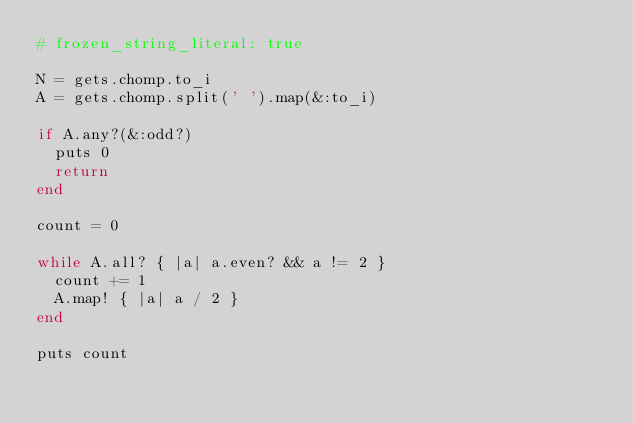<code> <loc_0><loc_0><loc_500><loc_500><_Ruby_># frozen_string_literal: true

N = gets.chomp.to_i
A = gets.chomp.split(' ').map(&:to_i)

if A.any?(&:odd?)
  puts 0
  return
end

count = 0

while A.all? { |a| a.even? && a != 2 }
  count += 1
  A.map! { |a| a / 2 }
end

puts count
</code> 